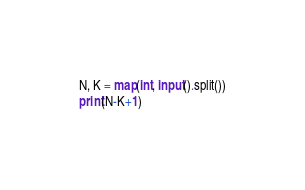Convert code to text. <code><loc_0><loc_0><loc_500><loc_500><_Python_>N, K = map(int, input().split())
print(N-K+1)</code> 